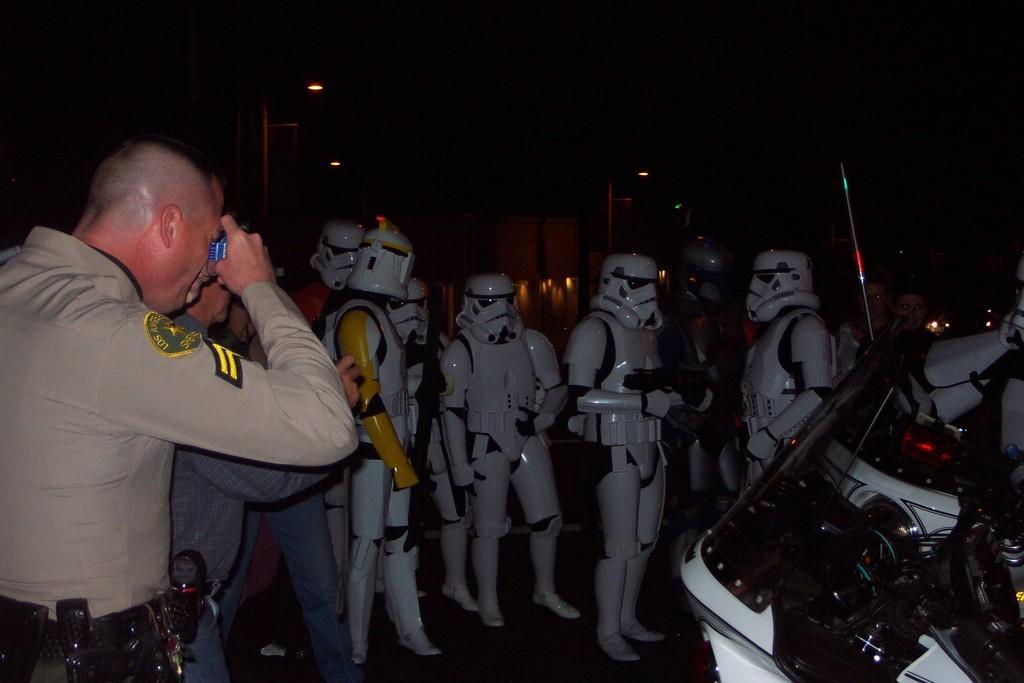Could you give a brief overview of what you see in this image? There are group of people in robotic costume and in the front, a man is clicking the images of those people there is a vehicle in the right side of that people,the image is captured in the night time. 